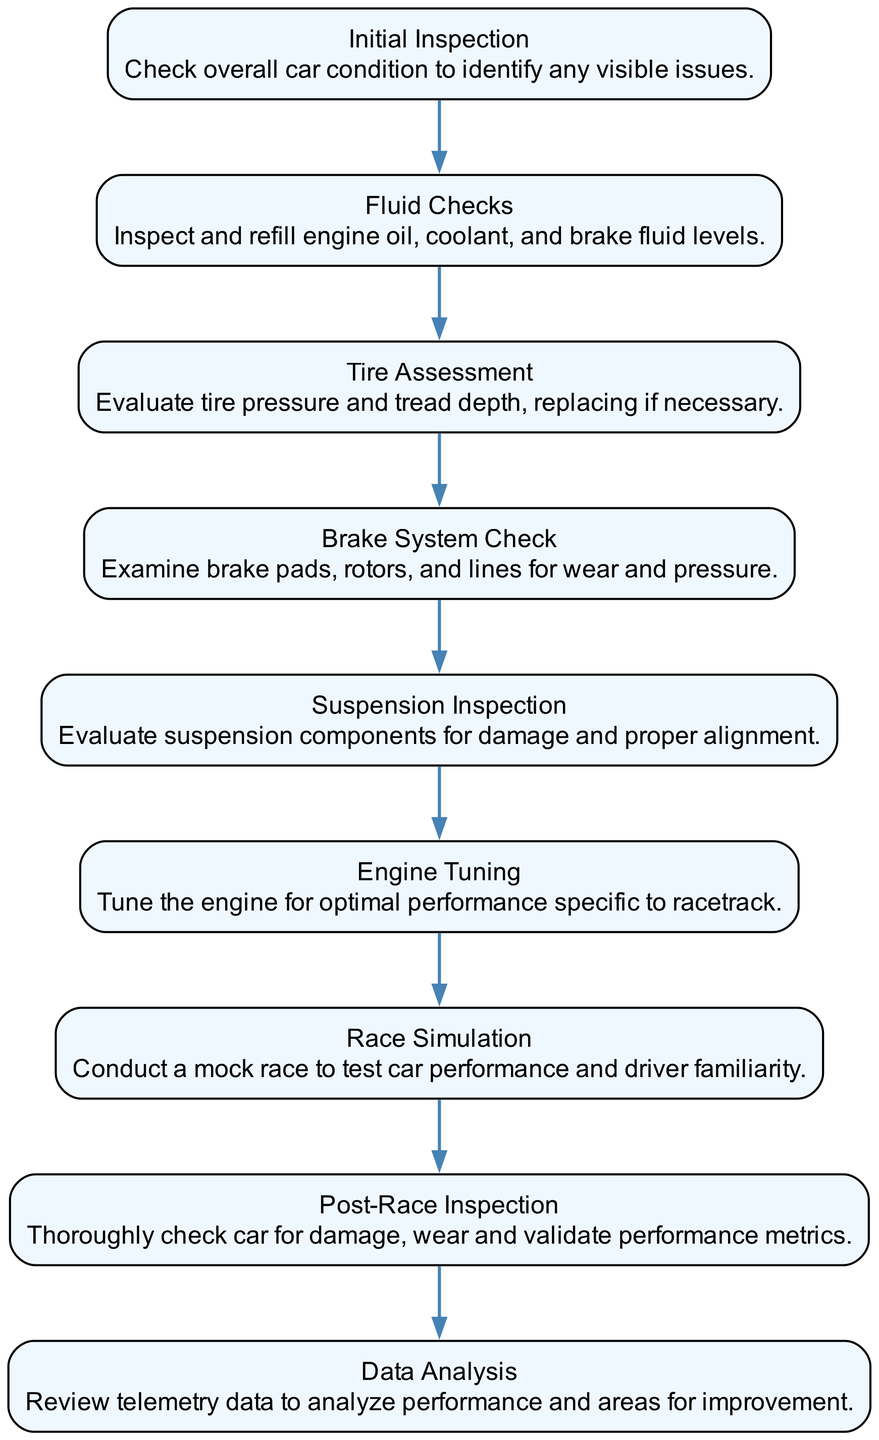What is the first maintenance task? The first maintenance task listed in the sequence is "Initial Inspection," which serves as the starting point for the maintenance process.
Answer: Initial Inspection How many maintenance tasks are there? Counting all the tasks listed in the diagram, there are a total of 9 maintenance tasks outlined from the initial inspection to data analysis.
Answer: 9 What task comes after "Fluid Checks"? The task that comes immediately after "Fluid Checks" is "Tire Assessment," which follows the order of the tasks as depicted in the sequence.
Answer: Tire Assessment Which task involves checking telemetry data? The task that involves reviewing telemetry data is "Data Analysis," which is the last task in the sequence.
Answer: Data Analysis How many tasks involve assessing or inspecting components? On review, there are 5 tasks that specifically involve assessing or inspecting components: "Initial Inspection," "Fluid Checks," "Tire Assessment," "Brake System Check," and "Suspension Inspection."
Answer: 5 What is the last maintenance task? The last maintenance task detailed in the sequence is "Data Analysis," which follows the post-race inspection phase.
Answer: Data Analysis Which task directly precedes the "Race Simulation"? "Engine Tuning" is the task that directly precedes "Race Simulation," as it is the task before it in the sequence flow.
Answer: Engine Tuning What type of maintenance does "Post-Race Inspection" represent? "Post-Race Inspection" represents a type of maintenance focused on evaluating the car after it has been raced, making it a post-race task.
Answer: Post-Race What is the significance of "Suspension Inspection"? "Suspension Inspection" is significant as it ensures that the car's suspension components are functioning properly, critical for vehicle performance and safety.
Answer: Evaluating suspension components 